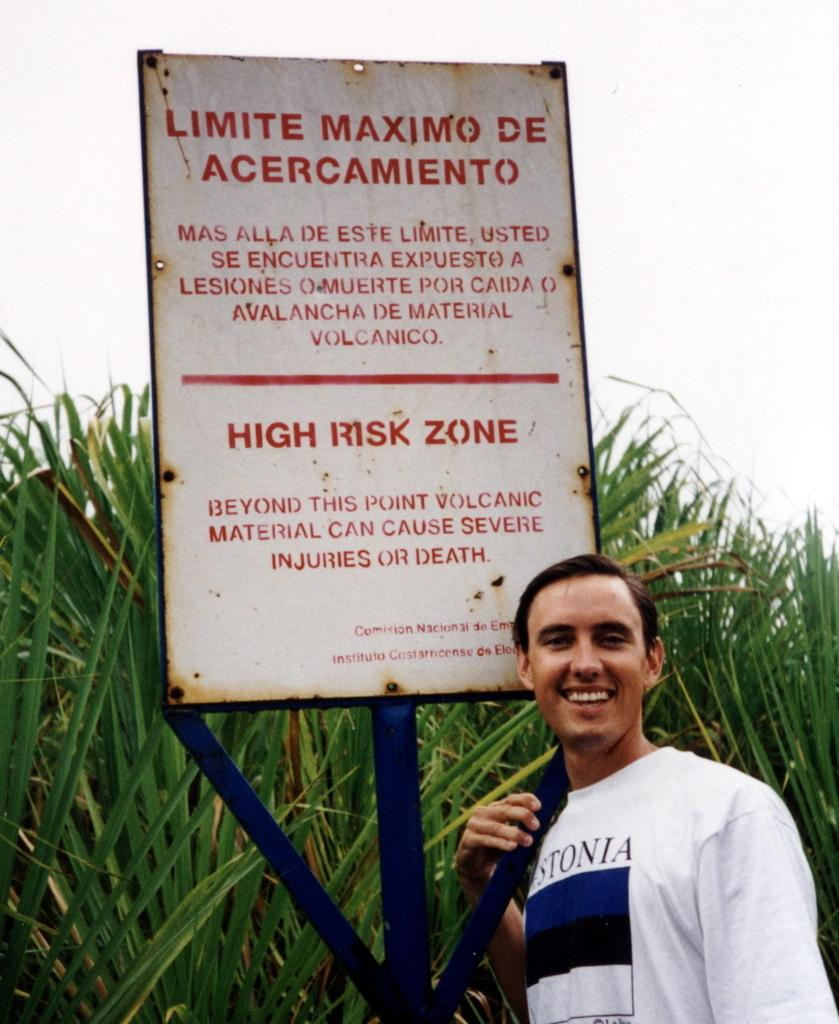Provide a one-sentence caption for the provided image. A man poses beneath a sign explaining the dangers of the volcanic area. 